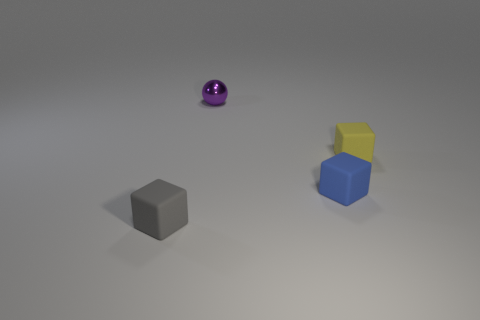Are there the same number of small blue things that are left of the tiny purple metal ball and brown shiny things? Yes, there is an equal number of small blue and brown objects; precisely, one small blue cube is to the left of the purple metallic sphere, and one brown cube is also in the scene, which aligns with the number of blue items mentioned. 